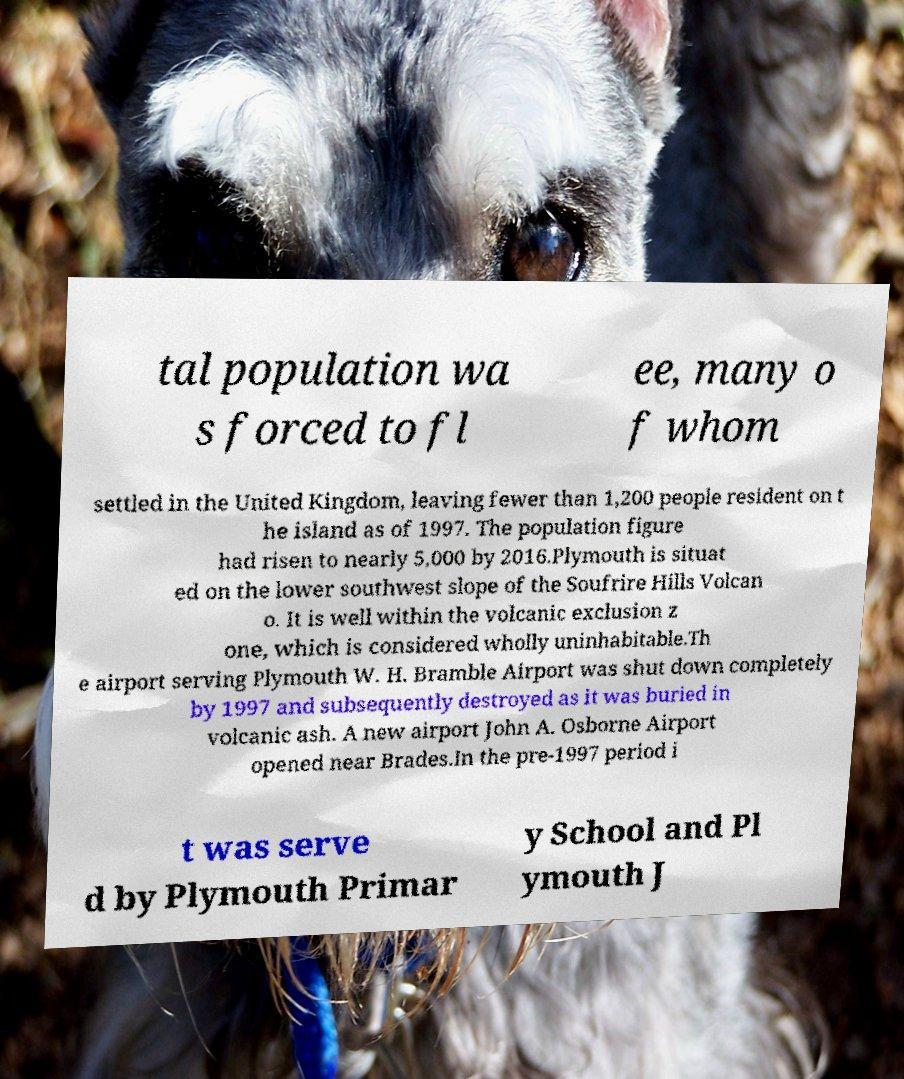Please read and relay the text visible in this image. What does it say? tal population wa s forced to fl ee, many o f whom settled in the United Kingdom, leaving fewer than 1,200 people resident on t he island as of 1997. The population figure had risen to nearly 5,000 by 2016.Plymouth is situat ed on the lower southwest slope of the Soufrire Hills Volcan o. It is well within the volcanic exclusion z one, which is considered wholly uninhabitable.Th e airport serving Plymouth W. H. Bramble Airport was shut down completely by 1997 and subsequently destroyed as it was buried in volcanic ash. A new airport John A. Osborne Airport opened near Brades.In the pre-1997 period i t was serve d by Plymouth Primar y School and Pl ymouth J 